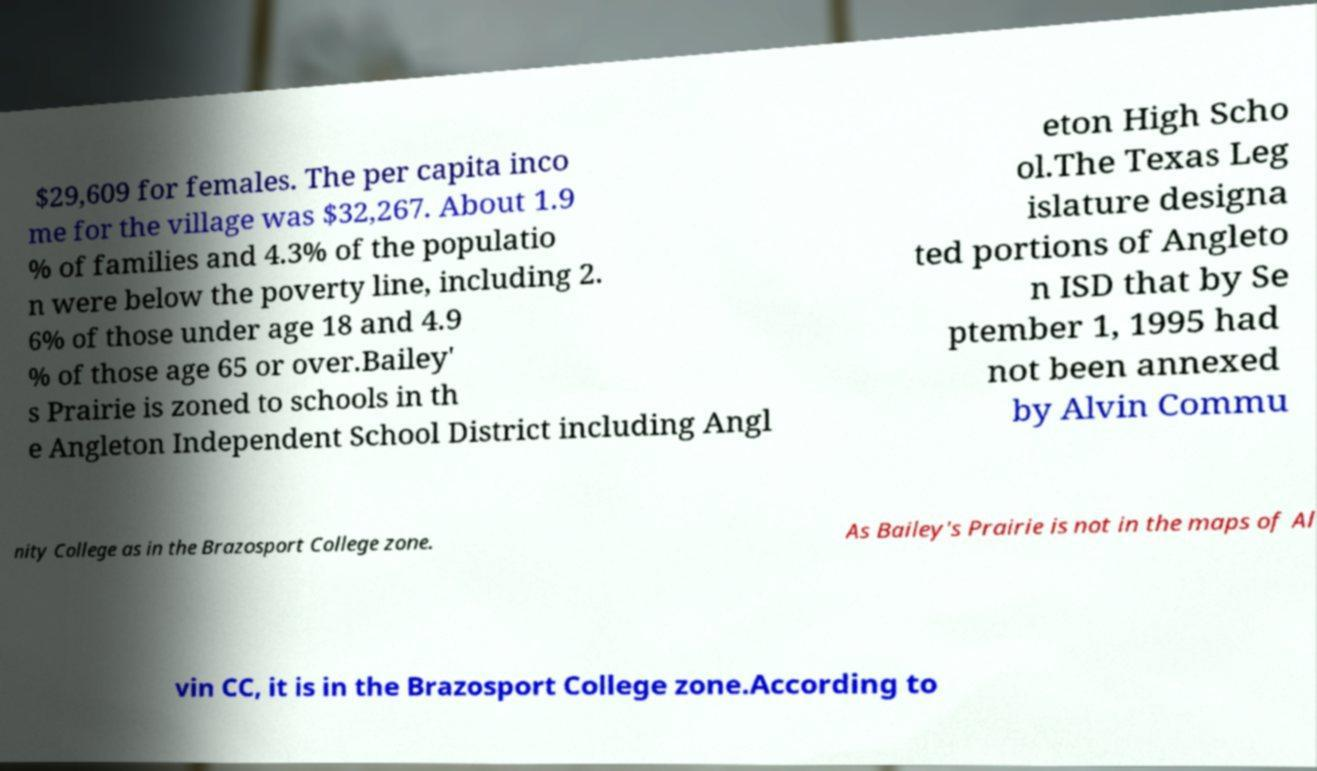There's text embedded in this image that I need extracted. Can you transcribe it verbatim? $29,609 for females. The per capita inco me for the village was $32,267. About 1.9 % of families and 4.3% of the populatio n were below the poverty line, including 2. 6% of those under age 18 and 4.9 % of those age 65 or over.Bailey' s Prairie is zoned to schools in th e Angleton Independent School District including Angl eton High Scho ol.The Texas Leg islature designa ted portions of Angleto n ISD that by Se ptember 1, 1995 had not been annexed by Alvin Commu nity College as in the Brazosport College zone. As Bailey's Prairie is not in the maps of Al vin CC, it is in the Brazosport College zone.According to 